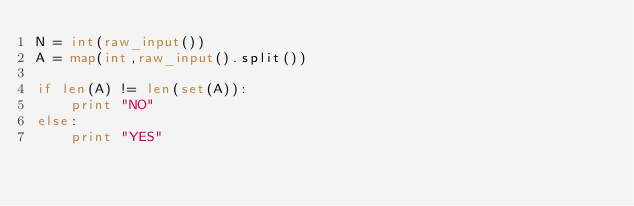<code> <loc_0><loc_0><loc_500><loc_500><_Python_>N = int(raw_input())
A = map(int,raw_input().split())

if len(A) != len(set(A)):
    print "NO"
else:
    print "YES"</code> 